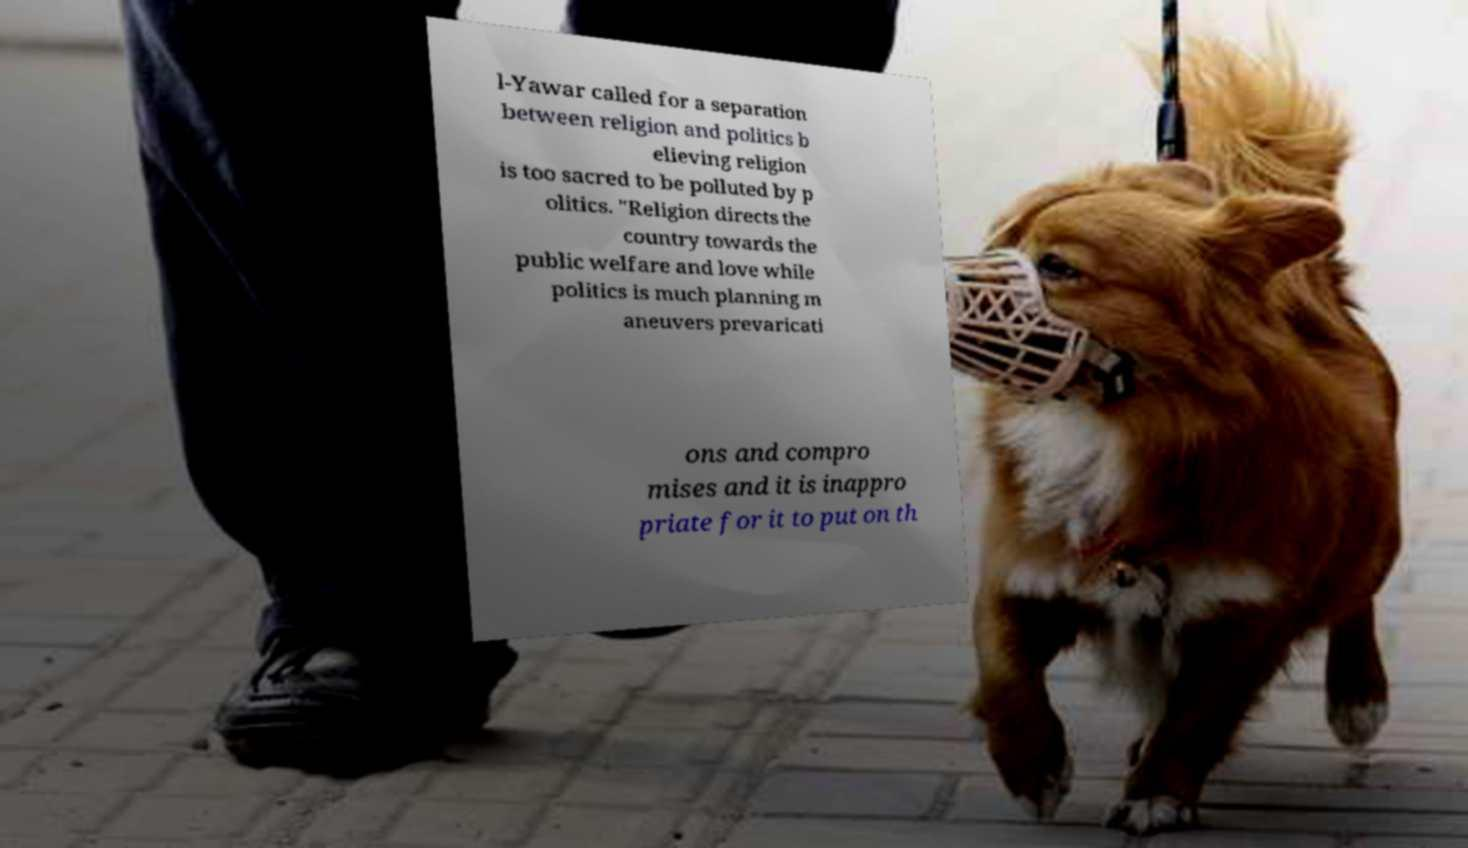Please identify and transcribe the text found in this image. l-Yawar called for a separation between religion and politics b elieving religion is too sacred to be polluted by p olitics. "Religion directs the country towards the public welfare and love while politics is much planning m aneuvers prevaricati ons and compro mises and it is inappro priate for it to put on th 